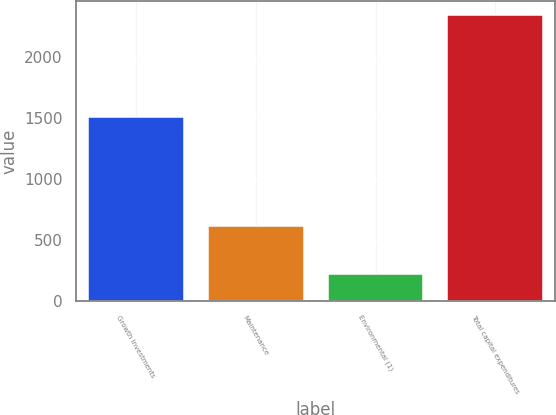<chart> <loc_0><loc_0><loc_500><loc_500><bar_chart><fcel>Growth Investments<fcel>Maintenance<fcel>Environmental (1)<fcel>Total capital expenditures<nl><fcel>1510<fcel>617<fcel>218<fcel>2345<nl></chart> 